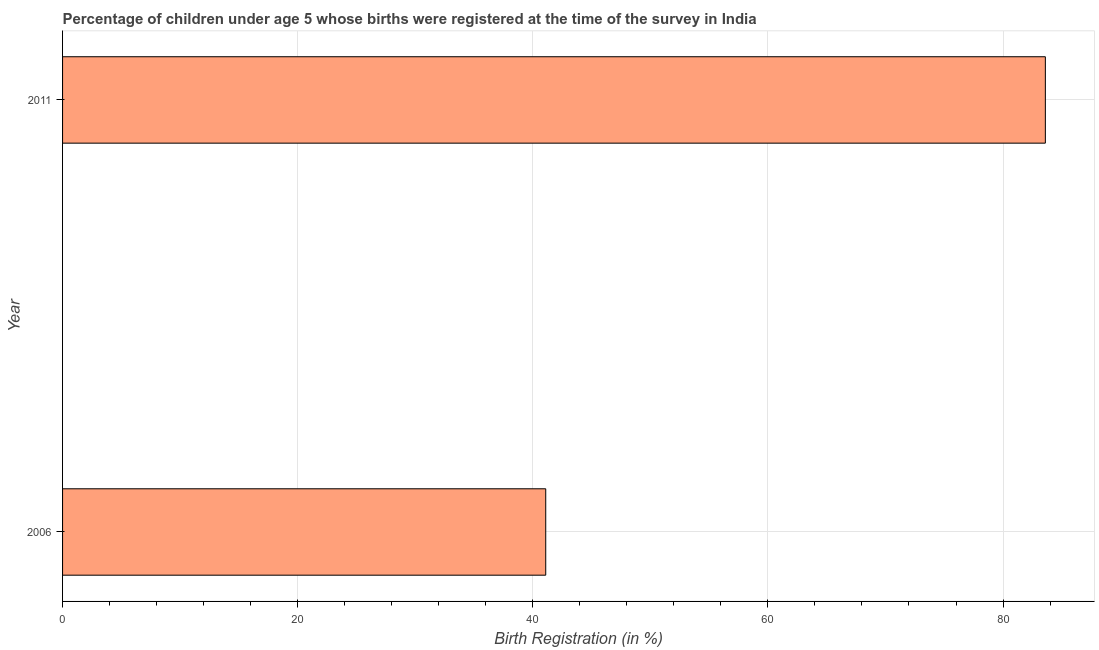Does the graph contain grids?
Your answer should be compact. Yes. What is the title of the graph?
Your response must be concise. Percentage of children under age 5 whose births were registered at the time of the survey in India. What is the label or title of the X-axis?
Your answer should be very brief. Birth Registration (in %). What is the label or title of the Y-axis?
Make the answer very short. Year. What is the birth registration in 2011?
Your response must be concise. 83.6. Across all years, what is the maximum birth registration?
Provide a short and direct response. 83.6. Across all years, what is the minimum birth registration?
Your answer should be compact. 41.1. In which year was the birth registration maximum?
Your answer should be compact. 2011. What is the sum of the birth registration?
Make the answer very short. 124.7. What is the difference between the birth registration in 2006 and 2011?
Offer a terse response. -42.5. What is the average birth registration per year?
Provide a succinct answer. 62.35. What is the median birth registration?
Ensure brevity in your answer.  62.35. Do a majority of the years between 2006 and 2011 (inclusive) have birth registration greater than 16 %?
Your answer should be very brief. Yes. What is the ratio of the birth registration in 2006 to that in 2011?
Provide a short and direct response. 0.49. Is the birth registration in 2006 less than that in 2011?
Your response must be concise. Yes. How many years are there in the graph?
Offer a terse response. 2. Are the values on the major ticks of X-axis written in scientific E-notation?
Offer a terse response. No. What is the Birth Registration (in %) of 2006?
Your response must be concise. 41.1. What is the Birth Registration (in %) in 2011?
Your answer should be compact. 83.6. What is the difference between the Birth Registration (in %) in 2006 and 2011?
Your response must be concise. -42.5. What is the ratio of the Birth Registration (in %) in 2006 to that in 2011?
Your answer should be very brief. 0.49. 